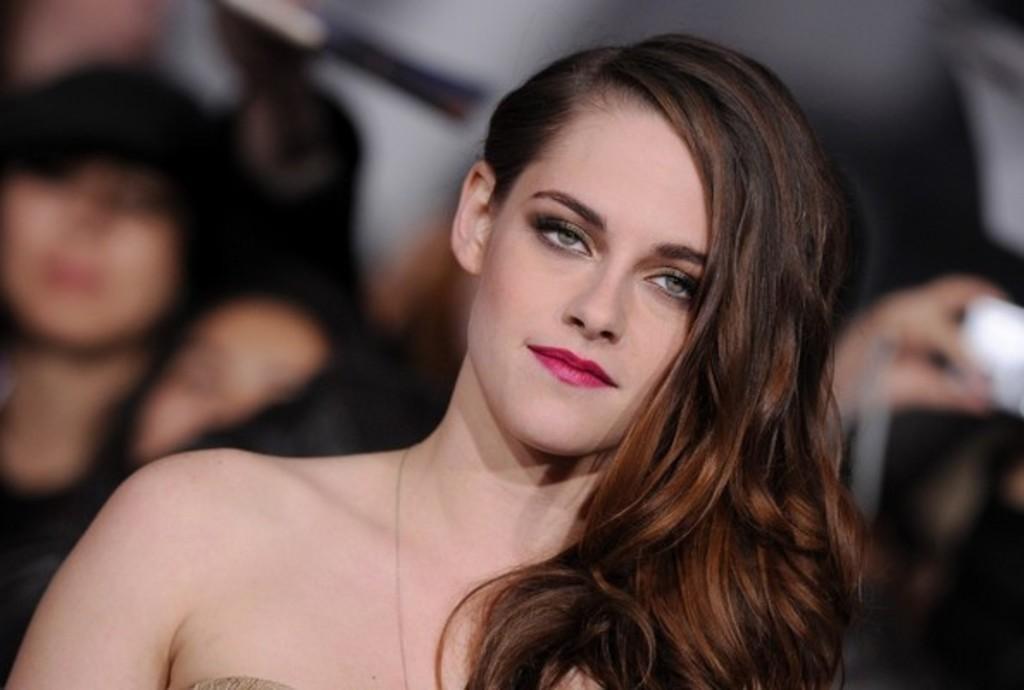Could you give a brief overview of what you see in this image? In this image I can see a woman. In the background I can see few more people and I can see this image is little bit blurry from background. 